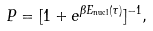<formula> <loc_0><loc_0><loc_500><loc_500>P = [ 1 + e ^ { \beta E _ { \text {nucl} } ( \tau ) } ] ^ { - 1 } ,</formula> 